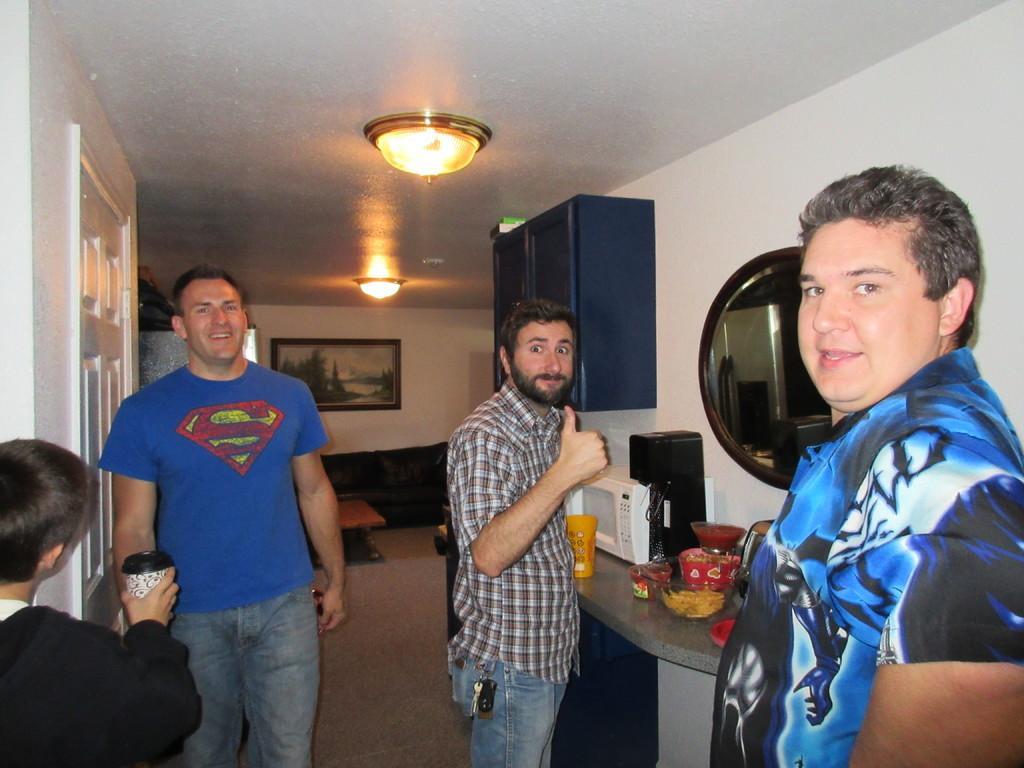In one or two sentences, can you explain what this image depicts? This picture is taken inside the room. In this image, on the right side, we can see a man wearing a blue color shirt. On the right side, we can also see another man standing in front of a the table, on the table, we can see a microwave oven and some food item. On the right side, we can see a mirror attached to a wall. On the right side, we can see an electronic machine. In the left corner, we can see a boy wearing a black color shirt and holding a glass in his hand. On the left side, we can see a person wearing a blue color shirt. On the left side, we can see a white color door. In the background, we can see a shelf, couch, pillows. In the background, we can also see a photo frame which is attached to a wall. At the top, we can see a roof with few lights. 